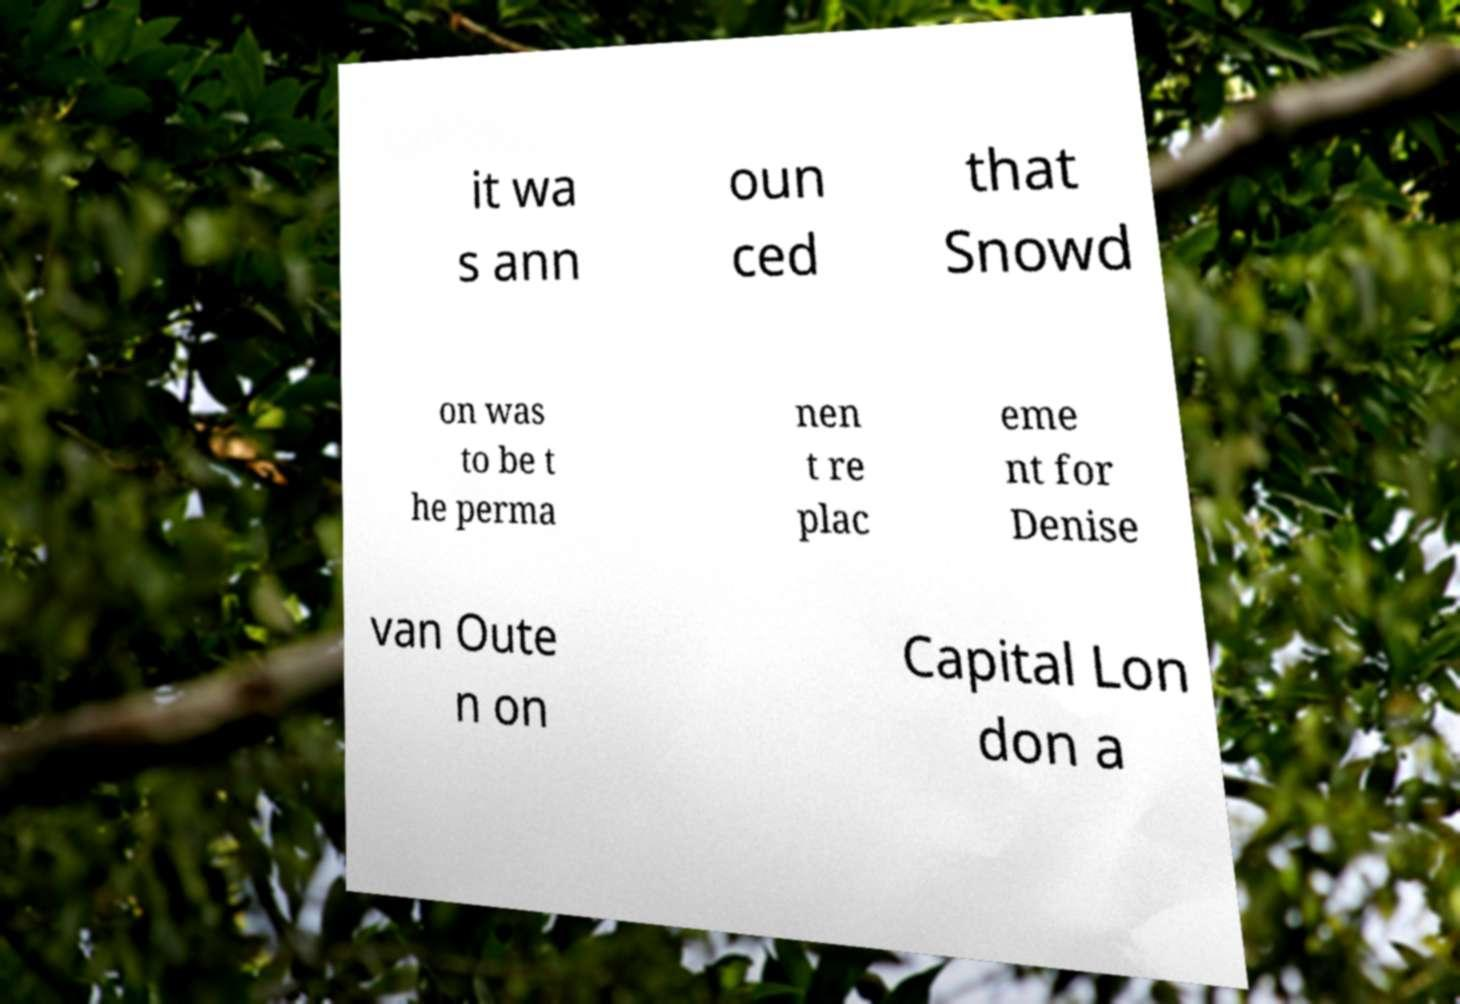What messages or text are displayed in this image? I need them in a readable, typed format. it wa s ann oun ced that Snowd on was to be t he perma nen t re plac eme nt for Denise van Oute n on Capital Lon don a 